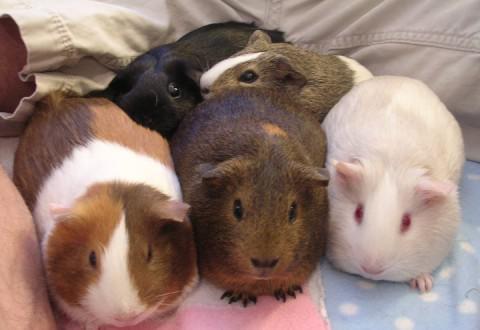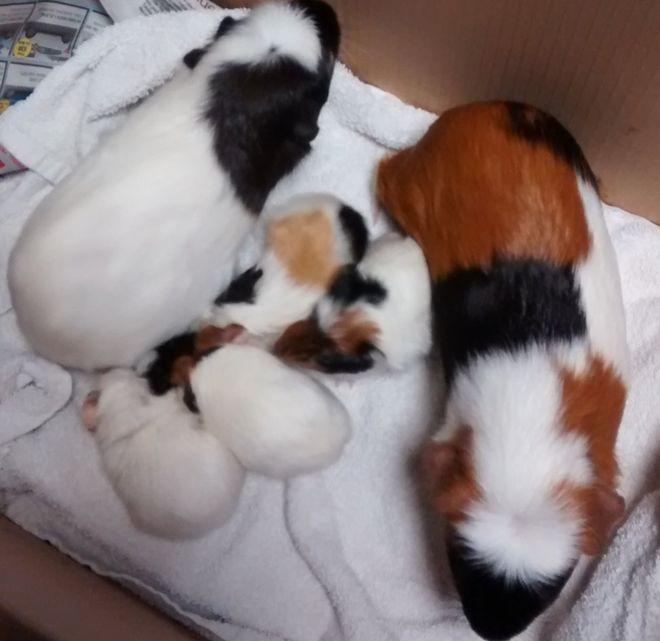The first image is the image on the left, the second image is the image on the right. For the images shown, is this caption "One of the images shows multiple guinea pigs on green grass." true? Answer yes or no. No. The first image is the image on the left, the second image is the image on the right. Assess this claim about the two images: "An image features at least five guinea pigs on green grass, and each image contains multiple guinea pigs.". Correct or not? Answer yes or no. No. 